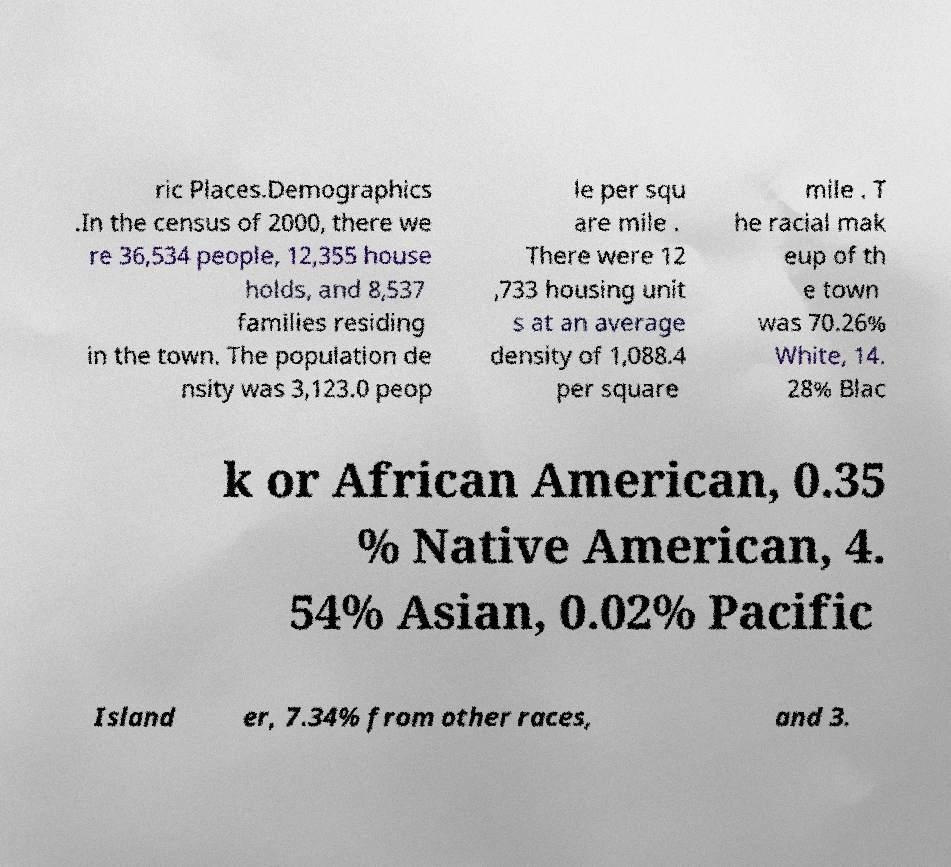Can you accurately transcribe the text from the provided image for me? ric Places.Demographics .In the census of 2000, there we re 36,534 people, 12,355 house holds, and 8,537 families residing in the town. The population de nsity was 3,123.0 peop le per squ are mile . There were 12 ,733 housing unit s at an average density of 1,088.4 per square mile . T he racial mak eup of th e town was 70.26% White, 14. 28% Blac k or African American, 0.35 % Native American, 4. 54% Asian, 0.02% Pacific Island er, 7.34% from other races, and 3. 